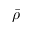Convert formula to latex. <formula><loc_0><loc_0><loc_500><loc_500>\bar { \rho }</formula> 